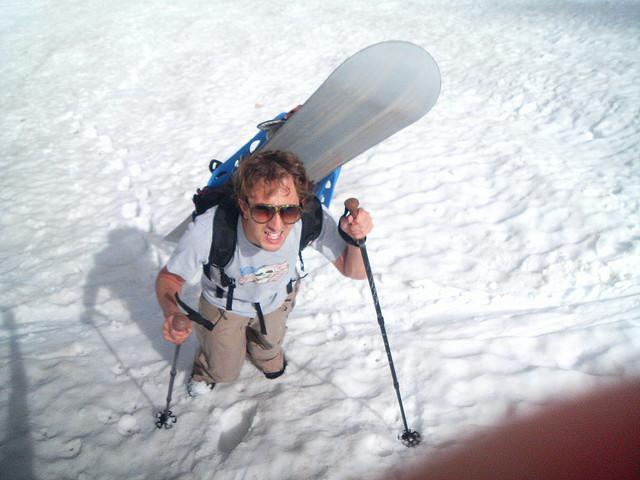How many of the people on the bench are holding umbrellas ?
Give a very brief answer. 0. 